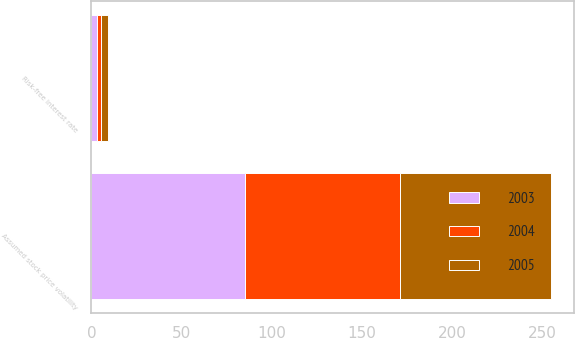<chart> <loc_0><loc_0><loc_500><loc_500><stacked_bar_chart><ecel><fcel>Risk-free interest rate<fcel>Assumed stock price volatility<nl><fcel>2003<fcel>2.92<fcel>85<nl><fcel>2004<fcel>2.56<fcel>86<nl><fcel>2005<fcel>3.87<fcel>84<nl></chart> 